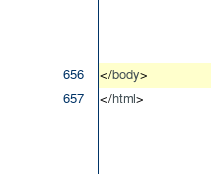Convert code to text. <code><loc_0><loc_0><loc_500><loc_500><_HTML_>
</body>
</html>
</code> 